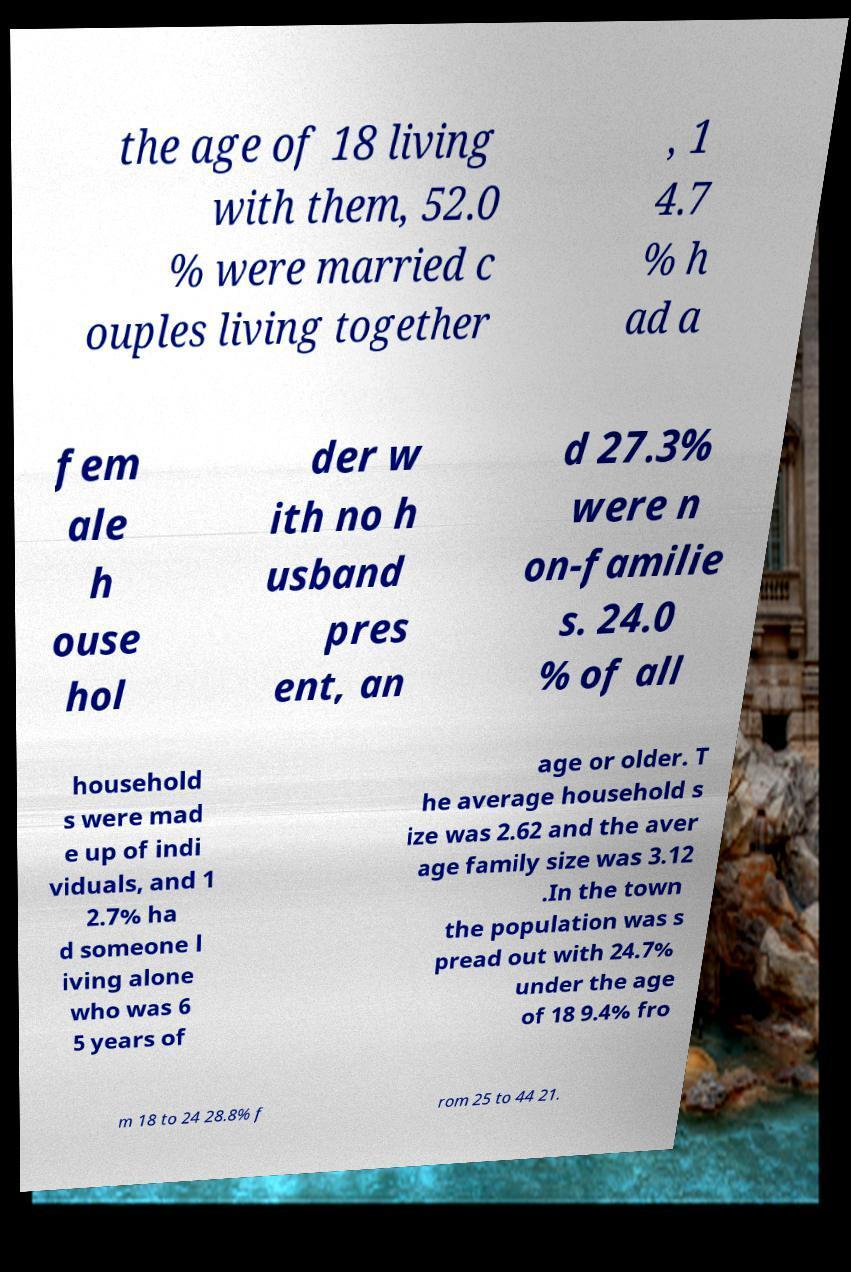Can you accurately transcribe the text from the provided image for me? the age of 18 living with them, 52.0 % were married c ouples living together , 1 4.7 % h ad a fem ale h ouse hol der w ith no h usband pres ent, an d 27.3% were n on-familie s. 24.0 % of all household s were mad e up of indi viduals, and 1 2.7% ha d someone l iving alone who was 6 5 years of age or older. T he average household s ize was 2.62 and the aver age family size was 3.12 .In the town the population was s pread out with 24.7% under the age of 18 9.4% fro m 18 to 24 28.8% f rom 25 to 44 21. 